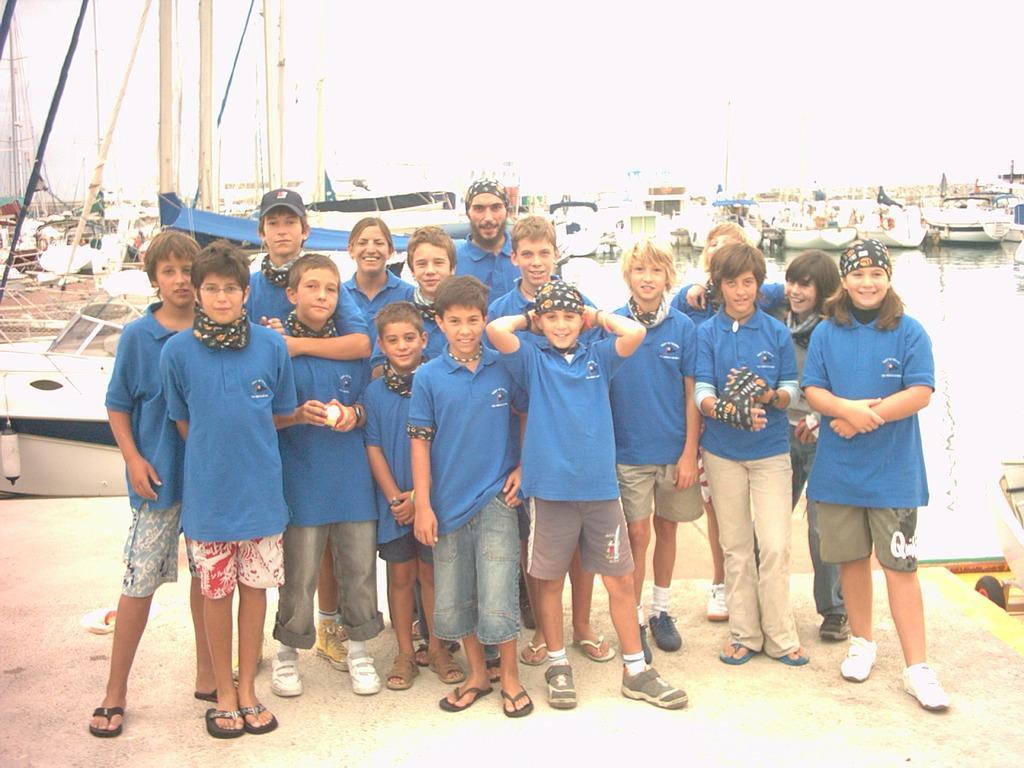Could you give a brief overview of what you see in this image? There are kids standing. In the background we can see ships above the water and we can see poles and sky. 